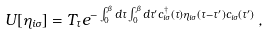Convert formula to latex. <formula><loc_0><loc_0><loc_500><loc_500>U [ \eta _ { i \sigma } ] = T _ { \tau } e ^ { - \int _ { 0 } ^ { \beta } d \tau \int _ { 0 } ^ { \beta } d \tau ^ { \prime } c ^ { \dagger } _ { i \sigma } ( \tau ) \eta _ { i \sigma } ( \tau - \tau ^ { \prime } ) c _ { i \sigma } ( \tau ^ { \prime } ) } \, ,</formula> 